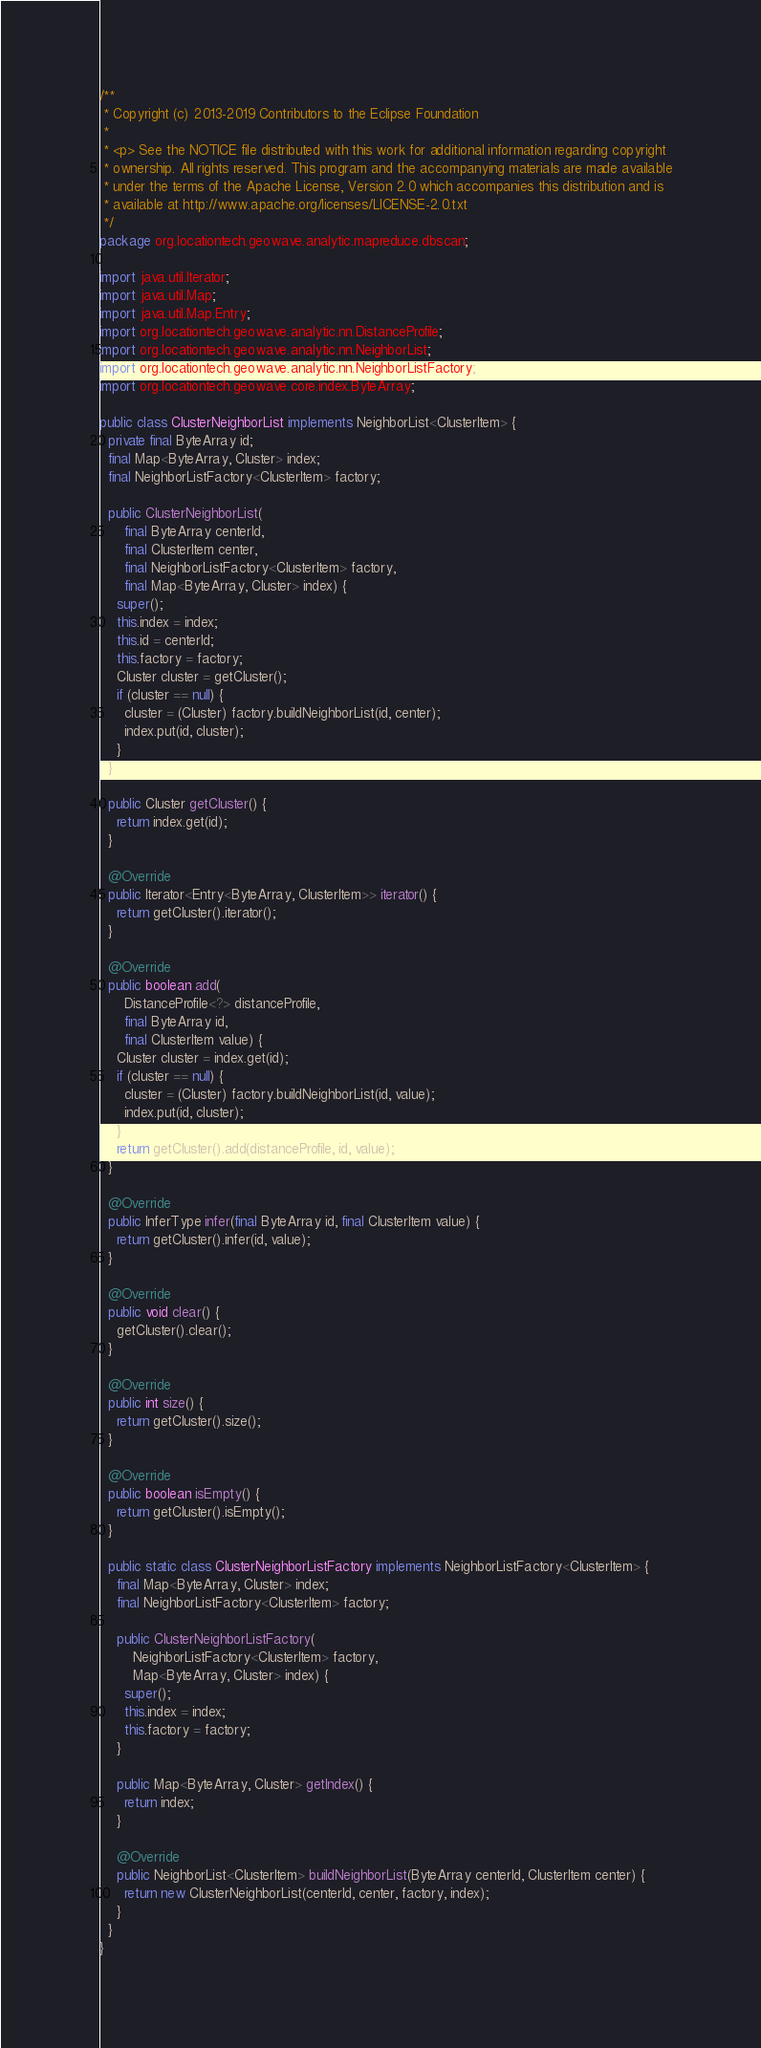<code> <loc_0><loc_0><loc_500><loc_500><_Java_>/**
 * Copyright (c) 2013-2019 Contributors to the Eclipse Foundation
 *
 * <p> See the NOTICE file distributed with this work for additional information regarding copyright
 * ownership. All rights reserved. This program and the accompanying materials are made available
 * under the terms of the Apache License, Version 2.0 which accompanies this distribution and is
 * available at http://www.apache.org/licenses/LICENSE-2.0.txt
 */
package org.locationtech.geowave.analytic.mapreduce.dbscan;

import java.util.Iterator;
import java.util.Map;
import java.util.Map.Entry;
import org.locationtech.geowave.analytic.nn.DistanceProfile;
import org.locationtech.geowave.analytic.nn.NeighborList;
import org.locationtech.geowave.analytic.nn.NeighborListFactory;
import org.locationtech.geowave.core.index.ByteArray;

public class ClusterNeighborList implements NeighborList<ClusterItem> {
  private final ByteArray id;
  final Map<ByteArray, Cluster> index;
  final NeighborListFactory<ClusterItem> factory;

  public ClusterNeighborList(
      final ByteArray centerId,
      final ClusterItem center,
      final NeighborListFactory<ClusterItem> factory,
      final Map<ByteArray, Cluster> index) {
    super();
    this.index = index;
    this.id = centerId;
    this.factory = factory;
    Cluster cluster = getCluster();
    if (cluster == null) {
      cluster = (Cluster) factory.buildNeighborList(id, center);
      index.put(id, cluster);
    }
  }

  public Cluster getCluster() {
    return index.get(id);
  }

  @Override
  public Iterator<Entry<ByteArray, ClusterItem>> iterator() {
    return getCluster().iterator();
  }

  @Override
  public boolean add(
      DistanceProfile<?> distanceProfile,
      final ByteArray id,
      final ClusterItem value) {
    Cluster cluster = index.get(id);
    if (cluster == null) {
      cluster = (Cluster) factory.buildNeighborList(id, value);
      index.put(id, cluster);
    }
    return getCluster().add(distanceProfile, id, value);
  }

  @Override
  public InferType infer(final ByteArray id, final ClusterItem value) {
    return getCluster().infer(id, value);
  }

  @Override
  public void clear() {
    getCluster().clear();
  }

  @Override
  public int size() {
    return getCluster().size();
  }

  @Override
  public boolean isEmpty() {
    return getCluster().isEmpty();
  }

  public static class ClusterNeighborListFactory implements NeighborListFactory<ClusterItem> {
    final Map<ByteArray, Cluster> index;
    final NeighborListFactory<ClusterItem> factory;

    public ClusterNeighborListFactory(
        NeighborListFactory<ClusterItem> factory,
        Map<ByteArray, Cluster> index) {
      super();
      this.index = index;
      this.factory = factory;
    }

    public Map<ByteArray, Cluster> getIndex() {
      return index;
    }

    @Override
    public NeighborList<ClusterItem> buildNeighborList(ByteArray centerId, ClusterItem center) {
      return new ClusterNeighborList(centerId, center, factory, index);
    }
  }
}
</code> 